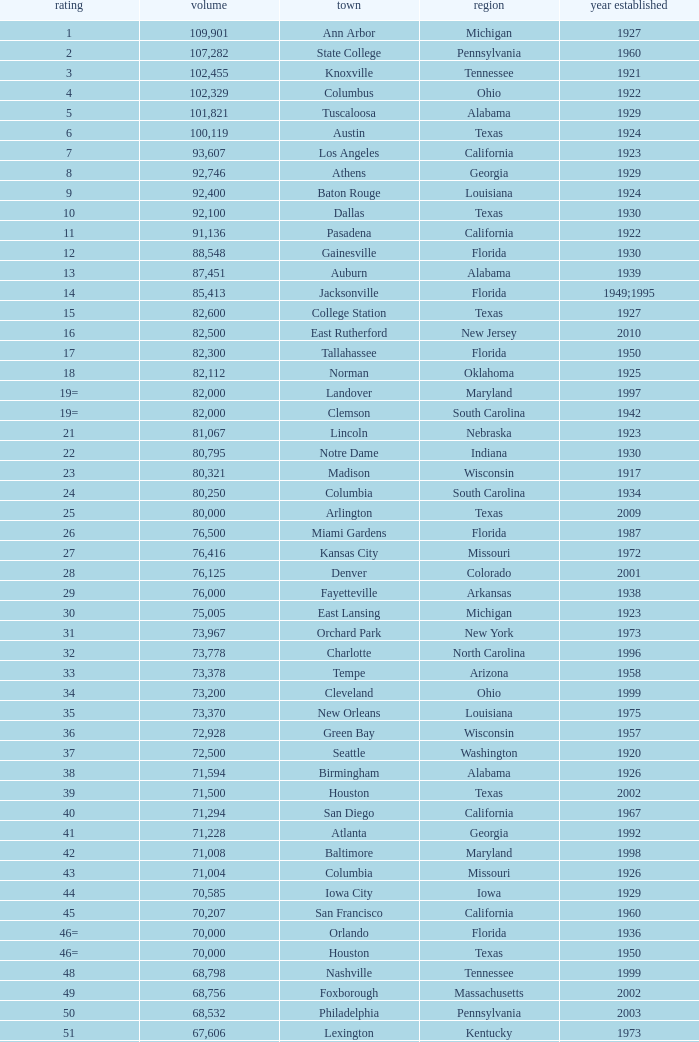What is the rank for the year opened in 1959 in Pennsylvania? 134=. 